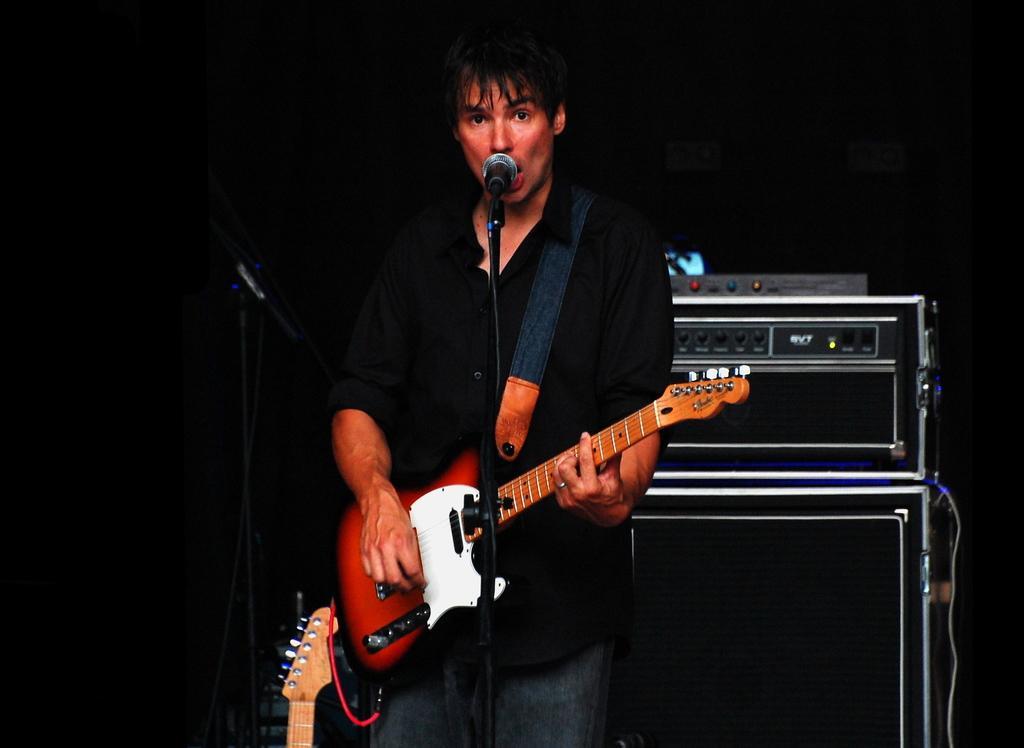Could you give a brief overview of what you see in this image? In this Image I see a man who is standing in front of a mic and he is holding a guitar, In the background I see an equipment and other musical instrument. 